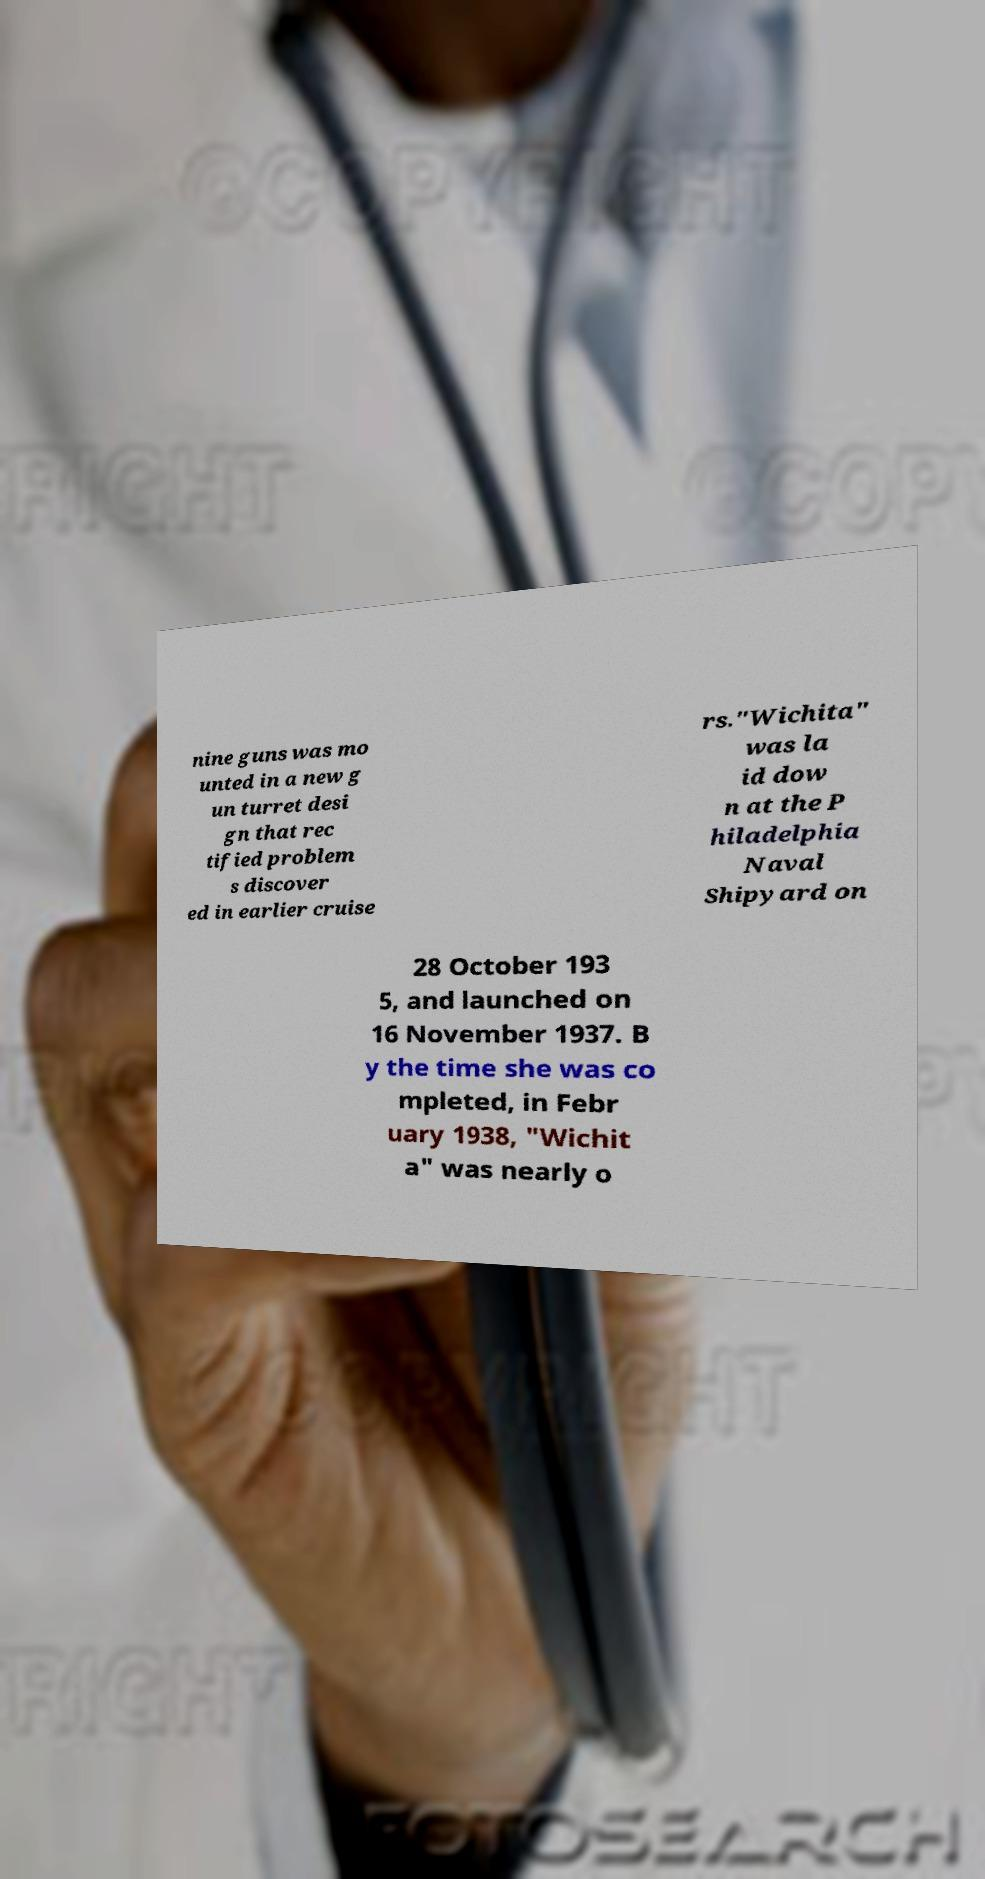Please identify and transcribe the text found in this image. nine guns was mo unted in a new g un turret desi gn that rec tified problem s discover ed in earlier cruise rs."Wichita" was la id dow n at the P hiladelphia Naval Shipyard on 28 October 193 5, and launched on 16 November 1937. B y the time she was co mpleted, in Febr uary 1938, "Wichit a" was nearly o 